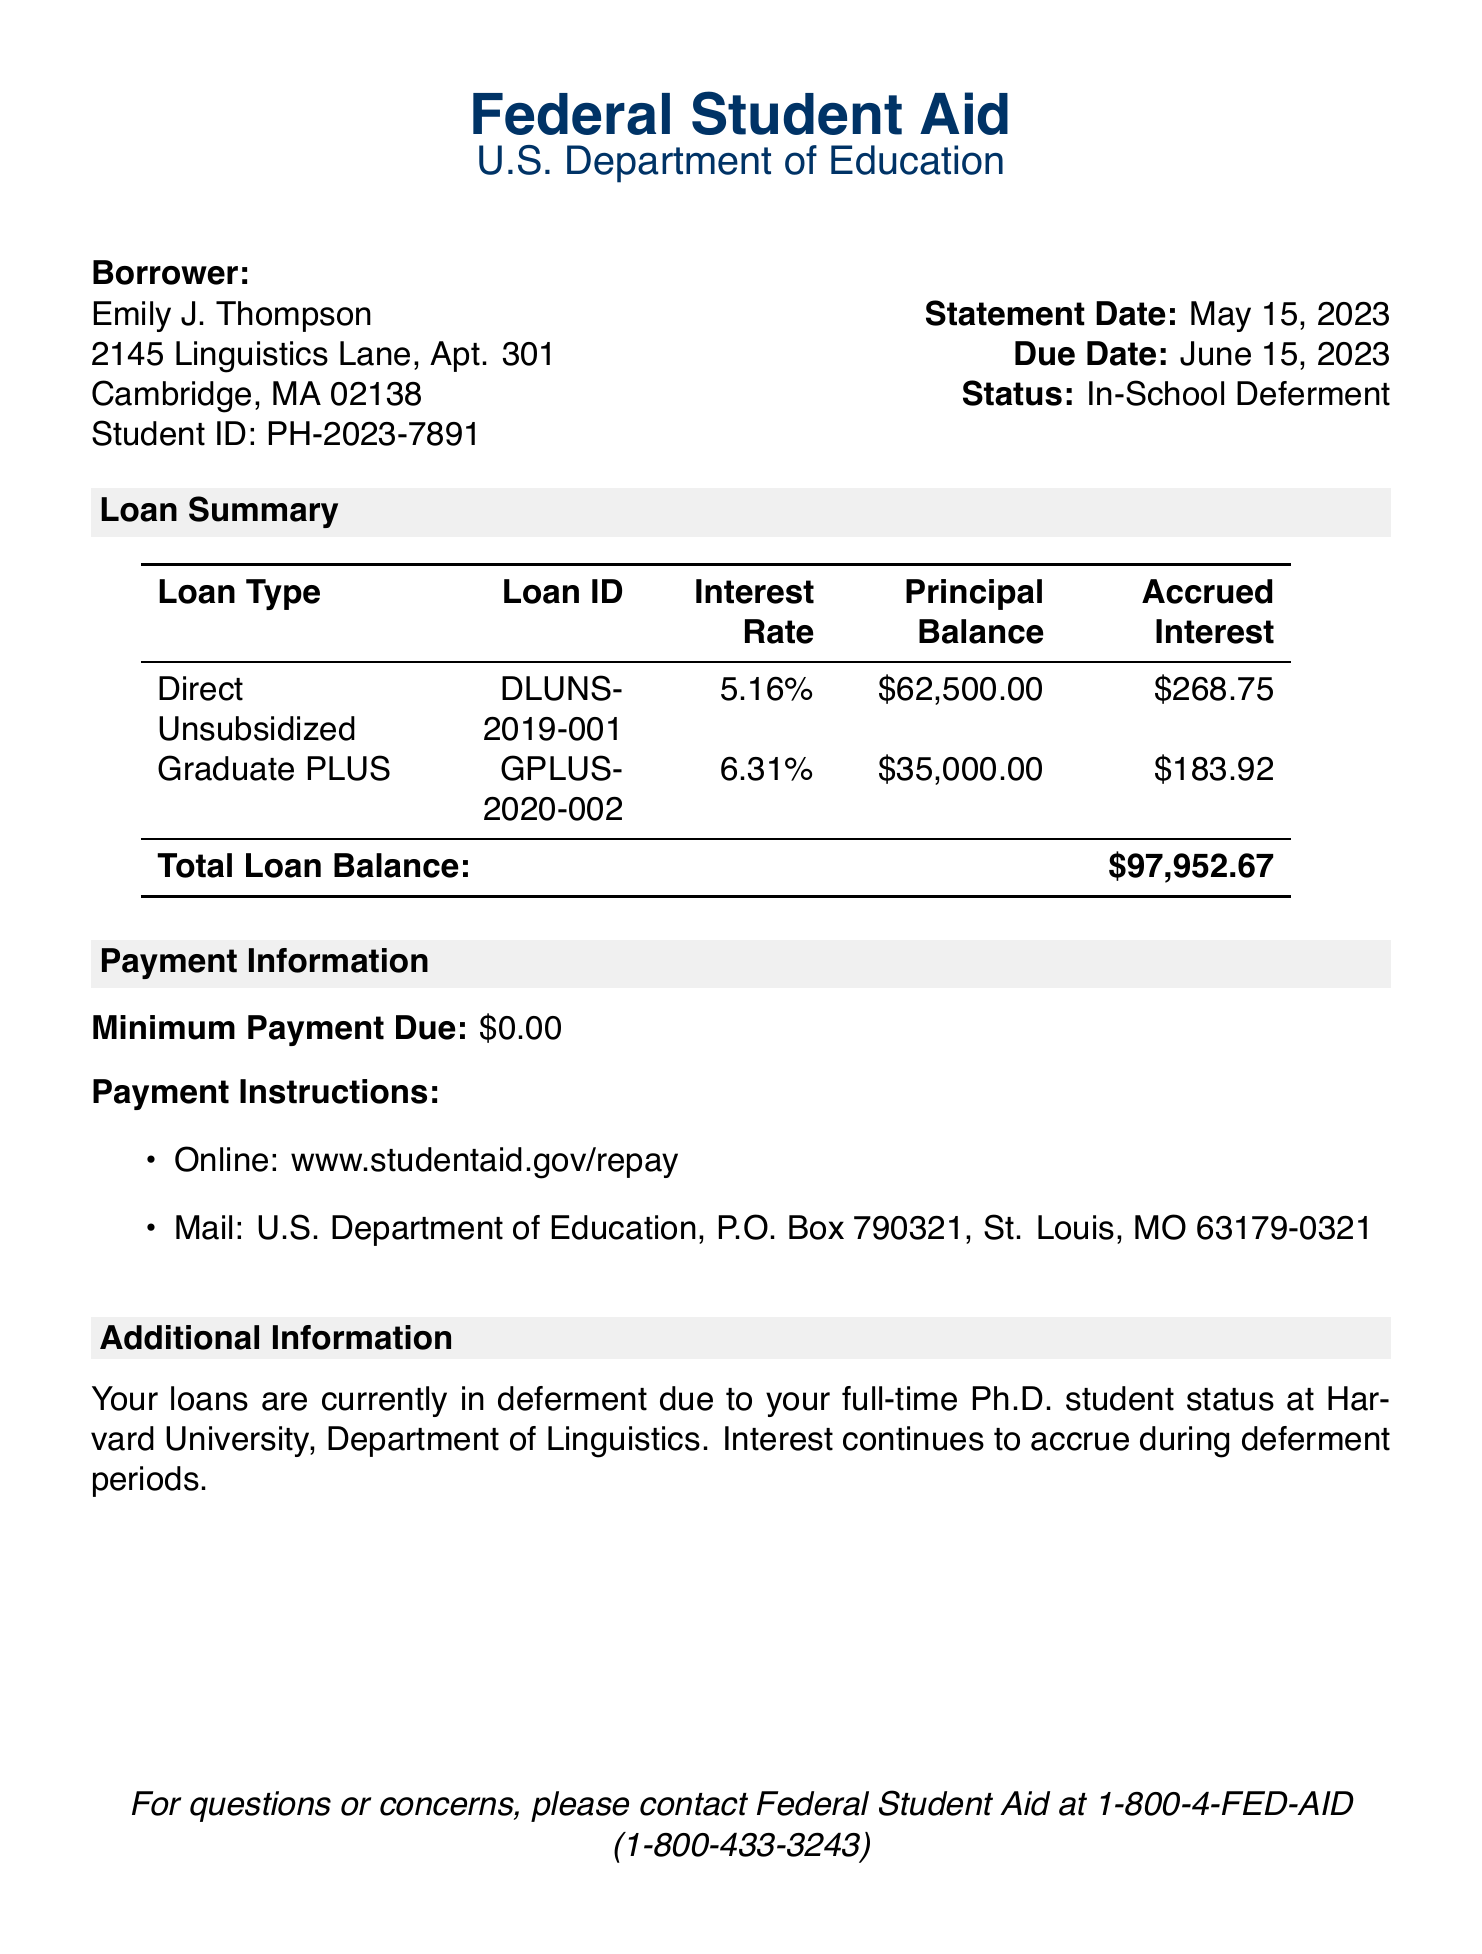What is the total principal balance? The total principal balance is the sum of all loan principal balances in the document, which is $62,500.00 + $35,000.00.
Answer: $97,500.00 What is the interest rate for the Graduate PLUS loan? The document specifies the interest rate for the Graduate PLUS loan as listed in the Loan Summary section.
Answer: 6.31% What is the borrower's Student ID? The Student ID for the borrower is provided in the borrower information section.
Answer: PH-2023-7891 When is the due date for the current statement? The document lists the due date in the header section.
Answer: June 15, 2023 What is the minimum payment due? The document states the minimum payment due under Payment Information.
Answer: $0.00 What type of deferment status does the borrower have? The document indicates the borrower's deferment status in the header section.
Answer: In-School Deferment What is the total accrued interest? The total accrued interest is the sum of the accrued interest for each loan type in the Loan Summary section.
Answer: $452.67 What should be done if there are questions or concerns? The document provides contact information for inquiries in the footer.
Answer: Contact Federal Student Aid at 1-800-4-FED-AID (1-800-433-3243) What is the loan type for the first listed loan? The loan type for the first loan in the Loan Summary section is specified.
Answer: Direct Unsubsidized 